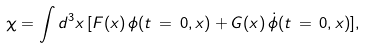<formula> <loc_0><loc_0><loc_500><loc_500>\chi = \int d ^ { 3 } x \, [ F ( x ) \, \phi ( t \, = \, 0 , x ) + G ( x ) \, \dot { \phi } ( t \, = \, 0 , x ) ] ,</formula> 